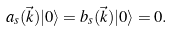Convert formula to latex. <formula><loc_0><loc_0><loc_500><loc_500>a _ { s } ( \vec { k } ) | 0 \rangle = b _ { s } ( \vec { k } ) | 0 \rangle = 0 .</formula> 